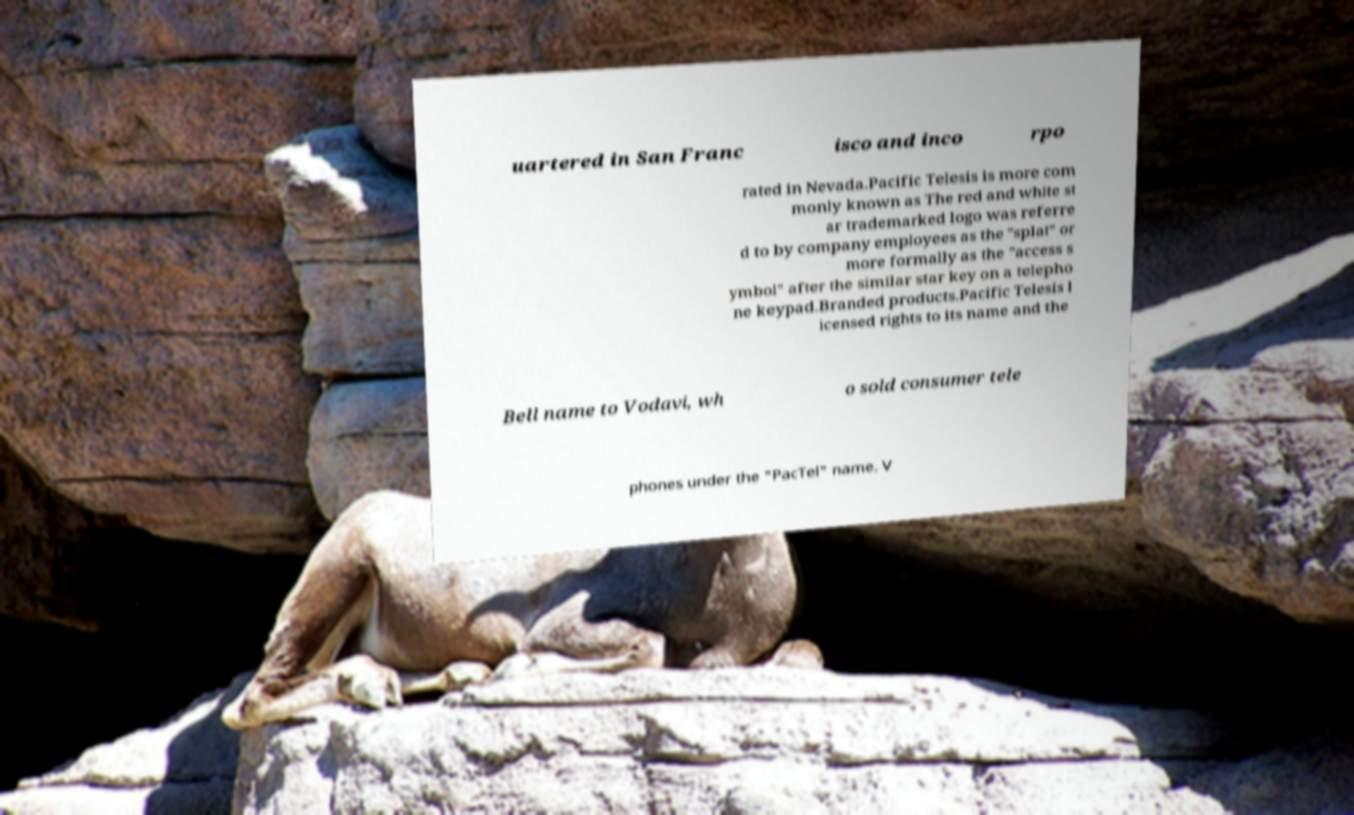Can you read and provide the text displayed in the image?This photo seems to have some interesting text. Can you extract and type it out for me? uartered in San Franc isco and inco rpo rated in Nevada.Pacific Telesis is more com monly known as The red and white st ar trademarked logo was referre d to by company employees as the "splat" or more formally as the "access s ymbol" after the similar star key on a telepho ne keypad.Branded products.Pacific Telesis l icensed rights to its name and the Bell name to Vodavi, wh o sold consumer tele phones under the "PacTel" name. V 